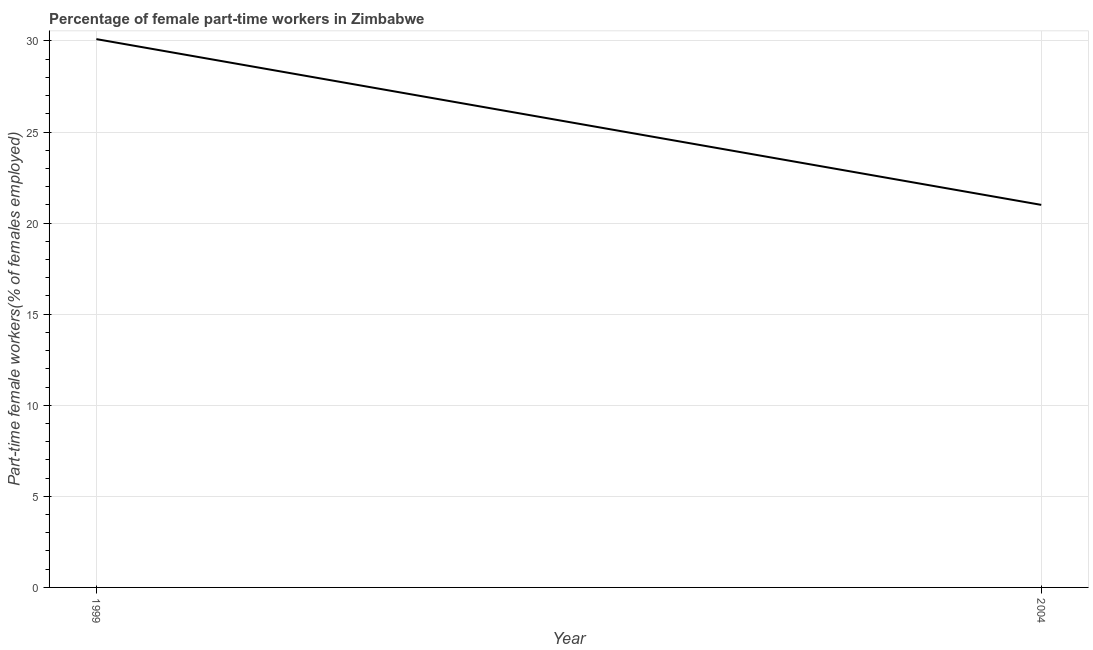What is the percentage of part-time female workers in 1999?
Provide a succinct answer. 30.1. Across all years, what is the maximum percentage of part-time female workers?
Make the answer very short. 30.1. Across all years, what is the minimum percentage of part-time female workers?
Make the answer very short. 21. In which year was the percentage of part-time female workers maximum?
Your answer should be very brief. 1999. In which year was the percentage of part-time female workers minimum?
Your response must be concise. 2004. What is the sum of the percentage of part-time female workers?
Provide a succinct answer. 51.1. What is the difference between the percentage of part-time female workers in 1999 and 2004?
Give a very brief answer. 9.1. What is the average percentage of part-time female workers per year?
Offer a terse response. 25.55. What is the median percentage of part-time female workers?
Make the answer very short. 25.55. Do a majority of the years between 1999 and 2004 (inclusive) have percentage of part-time female workers greater than 26 %?
Keep it short and to the point. No. What is the ratio of the percentage of part-time female workers in 1999 to that in 2004?
Offer a very short reply. 1.43. Is the percentage of part-time female workers in 1999 less than that in 2004?
Offer a very short reply. No. In how many years, is the percentage of part-time female workers greater than the average percentage of part-time female workers taken over all years?
Offer a very short reply. 1. How many lines are there?
Your answer should be very brief. 1. Are the values on the major ticks of Y-axis written in scientific E-notation?
Provide a succinct answer. No. What is the title of the graph?
Ensure brevity in your answer.  Percentage of female part-time workers in Zimbabwe. What is the label or title of the Y-axis?
Keep it short and to the point. Part-time female workers(% of females employed). What is the Part-time female workers(% of females employed) in 1999?
Your answer should be very brief. 30.1. What is the difference between the Part-time female workers(% of females employed) in 1999 and 2004?
Make the answer very short. 9.1. What is the ratio of the Part-time female workers(% of females employed) in 1999 to that in 2004?
Make the answer very short. 1.43. 